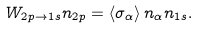<formula> <loc_0><loc_0><loc_500><loc_500>W _ { 2 p \rightarrow 1 s } n _ { 2 p } = \left \langle \sigma _ { \alpha } \right \rangle n _ { \alpha } n _ { 1 s } .</formula> 